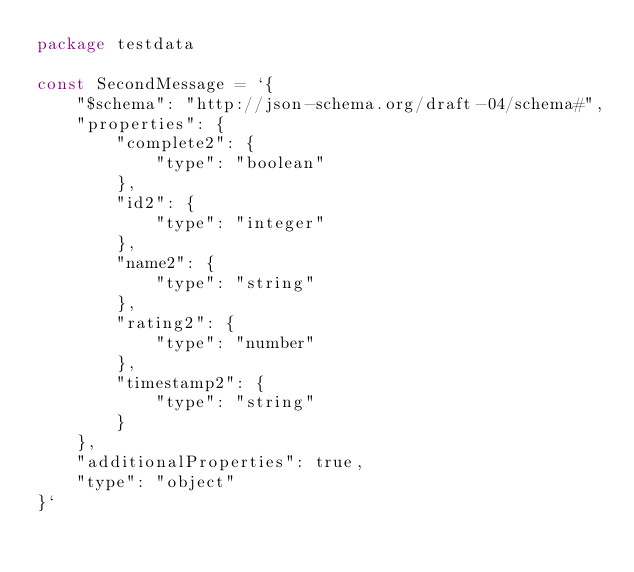<code> <loc_0><loc_0><loc_500><loc_500><_Go_>package testdata

const SecondMessage = `{
    "$schema": "http://json-schema.org/draft-04/schema#",
    "properties": {
        "complete2": {
            "type": "boolean"
        },
        "id2": {
            "type": "integer"
        },
        "name2": {
            "type": "string"
        },
        "rating2": {
            "type": "number"
        },
        "timestamp2": {
            "type": "string"
        }
    },
    "additionalProperties": true,
    "type": "object"
}`
</code> 